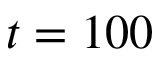Convert formula to latex. <formula><loc_0><loc_0><loc_500><loc_500>t = 1 0 0</formula> 